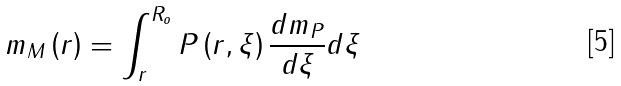<formula> <loc_0><loc_0><loc_500><loc_500>m _ { M } \left ( r \right ) = \int _ { r } ^ { R _ { o } } P \left ( r , \xi \right ) \frac { d m _ { P } } { d \xi } d \xi</formula> 